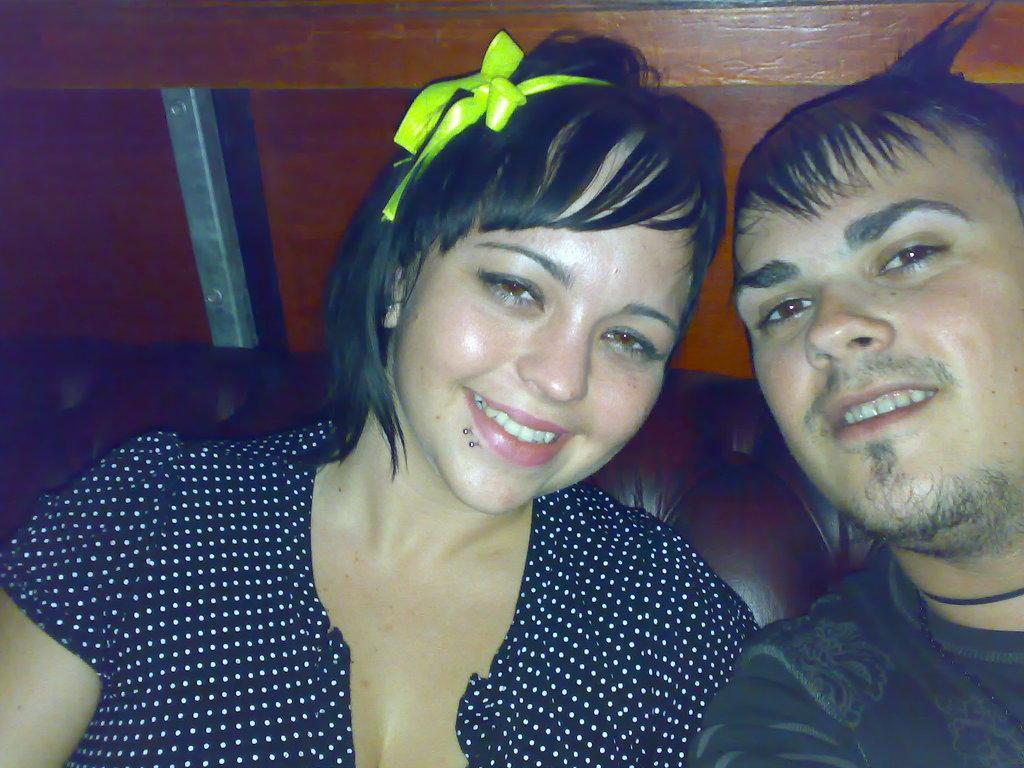Can you describe this image briefly? In the image I can see a man and woman are smiling. These people are wearing dark color clothes. In the background I can see some objects. These people are smiling. 